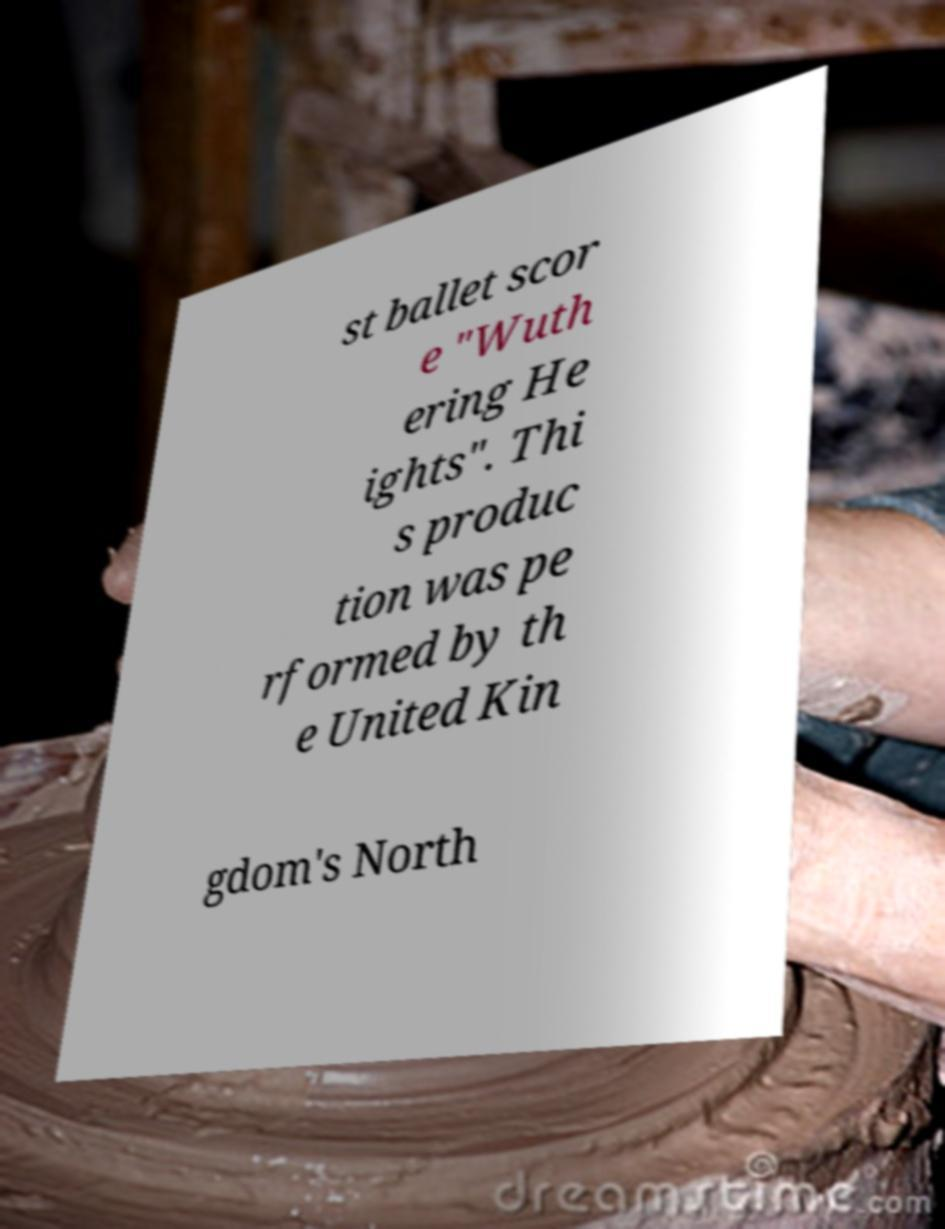Could you assist in decoding the text presented in this image and type it out clearly? st ballet scor e "Wuth ering He ights". Thi s produc tion was pe rformed by th e United Kin gdom's North 